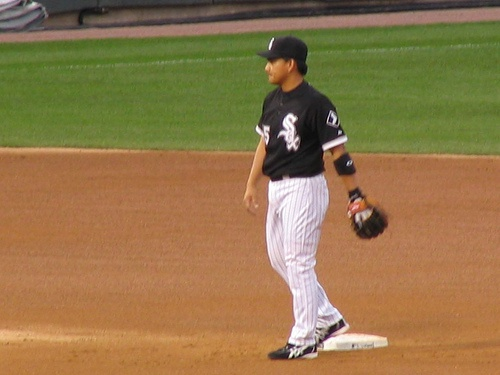Describe the objects in this image and their specific colors. I can see people in lightgray, black, lavender, salmon, and darkgray tones and baseball glove in lightgray, black, maroon, and brown tones in this image. 